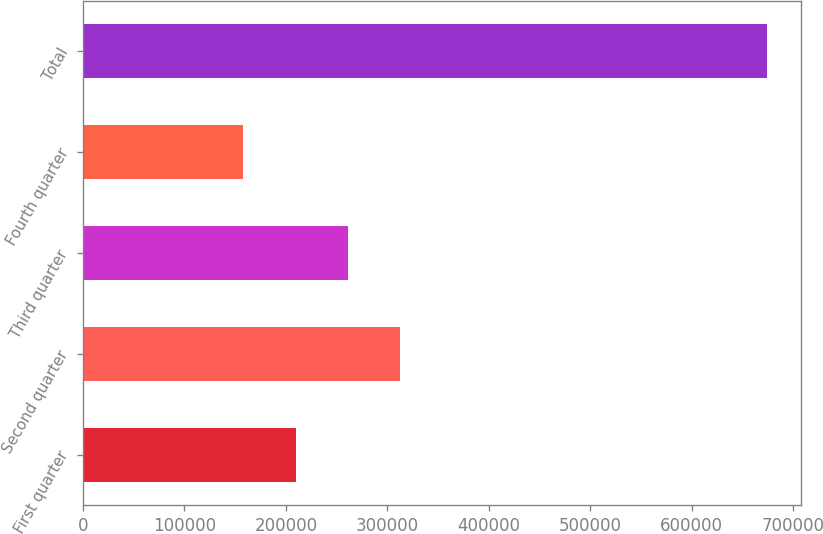<chart> <loc_0><loc_0><loc_500><loc_500><bar_chart><fcel>First quarter<fcel>Second quarter<fcel>Third quarter<fcel>Fourth quarter<fcel>Total<nl><fcel>209751<fcel>312952<fcel>261352<fcel>158151<fcel>674155<nl></chart> 